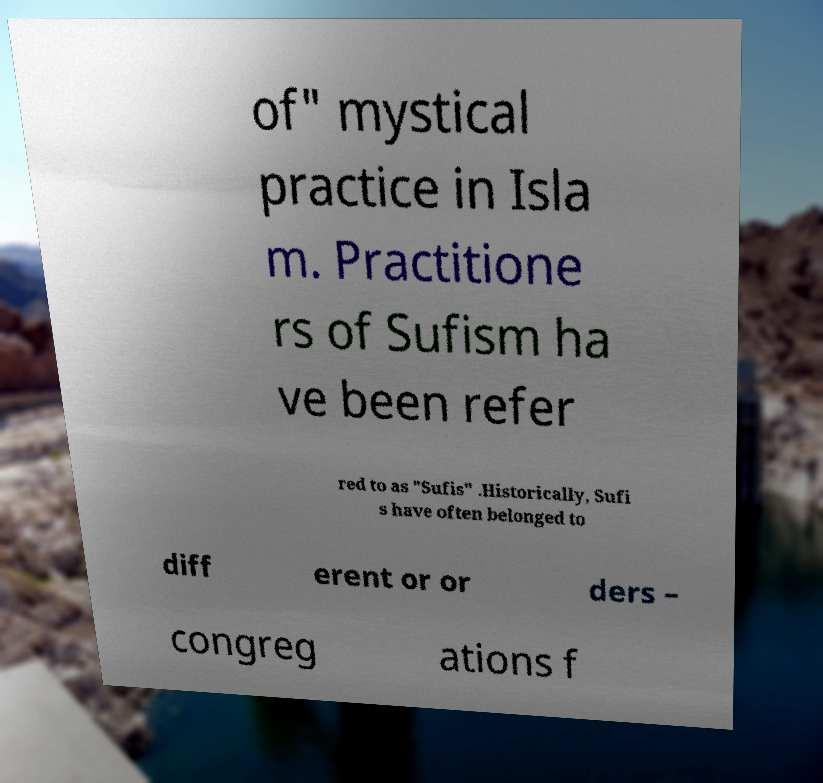Can you read and provide the text displayed in the image?This photo seems to have some interesting text. Can you extract and type it out for me? of" mystical practice in Isla m. Practitione rs of Sufism ha ve been refer red to as "Sufis" .Historically, Sufi s have often belonged to diff erent or or ders – congreg ations f 